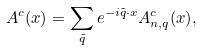<formula> <loc_0><loc_0><loc_500><loc_500>A ^ { c } ( x ) = \sum _ { \tilde { q } } e ^ { - i \tilde { q } \cdot x } A _ { n , q } ^ { c } ( x ) ,</formula> 